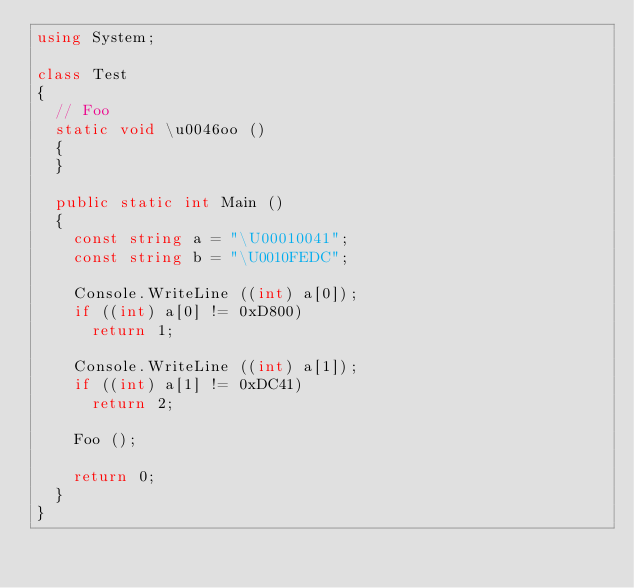<code> <loc_0><loc_0><loc_500><loc_500><_C#_>using System;

class Test
{
	// Foo
	static void \u0046oo () 
	{
	}
	
	public static int Main ()
	{
		const string a = "\U00010041";
		const string b = "\U0010FEDC";
		
		Console.WriteLine ((int) a[0]);
		if ((int) a[0] != 0xD800)
			return 1;

		Console.WriteLine ((int) a[1]);
		if ((int) a[1] != 0xDC41)
			return 2;
		
		Foo ();
		
		return 0;
	}
}

</code> 